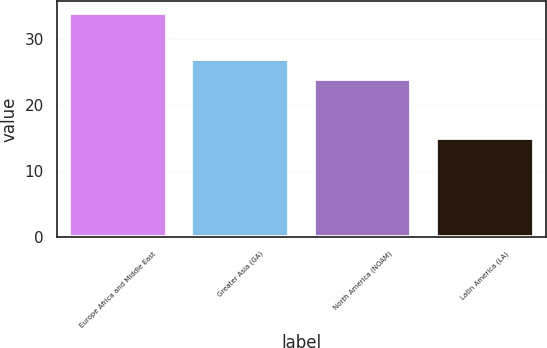Convert chart to OTSL. <chart><loc_0><loc_0><loc_500><loc_500><bar_chart><fcel>Europe Africa and Middle East<fcel>Greater Asia (GA)<fcel>North America (NOAM)<fcel>Latin America (LA)<nl><fcel>34<fcel>27<fcel>24<fcel>15<nl></chart> 